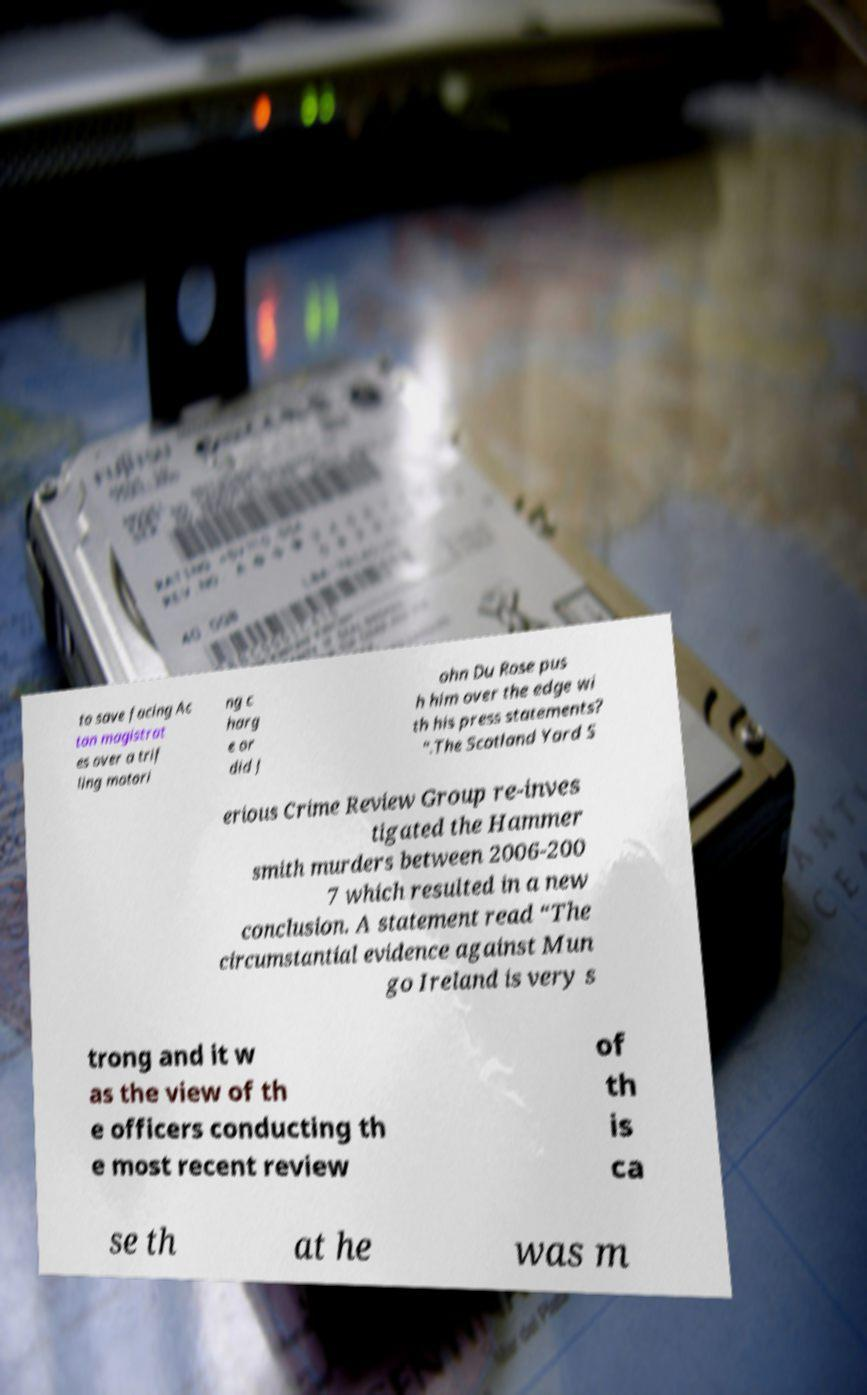Can you accurately transcribe the text from the provided image for me? to save facing Ac ton magistrat es over a trif ling motori ng c harg e or did J ohn Du Rose pus h him over the edge wi th his press statements? ".The Scotland Yard S erious Crime Review Group re-inves tigated the Hammer smith murders between 2006-200 7 which resulted in a new conclusion. A statement read “The circumstantial evidence against Mun go Ireland is very s trong and it w as the view of th e officers conducting th e most recent review of th is ca se th at he was m 